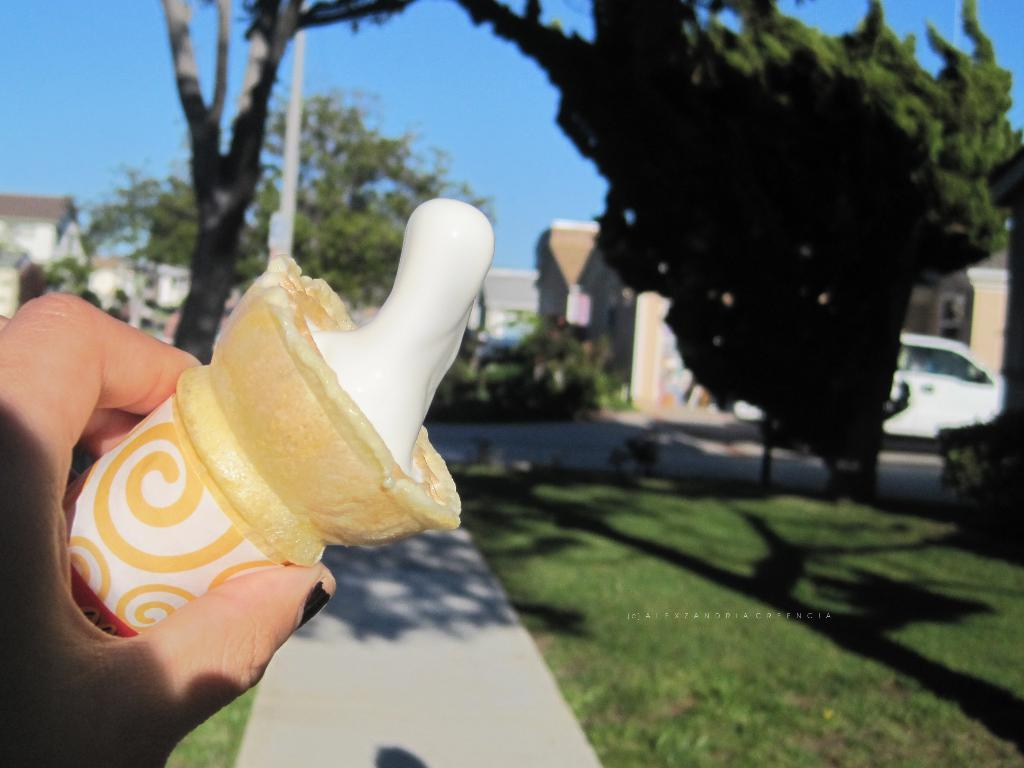What is the main subject of the image? There is an ice cream in the image. How is the ice cream being held? The ice cream is being held in someone's hand. What can be seen in the background of the image? There is a tree and a path in the background of the image. How is the background of the image depicted? The background is blurred. What type of sheet is covering the crib in the image? There is no crib or sheet present in the image. How does the person holding the ice cream express regret in the image? There is no indication of regret in the image, as it only shows a person holding an ice cream. 